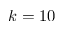Convert formula to latex. <formula><loc_0><loc_0><loc_500><loc_500>k = 1 0</formula> 